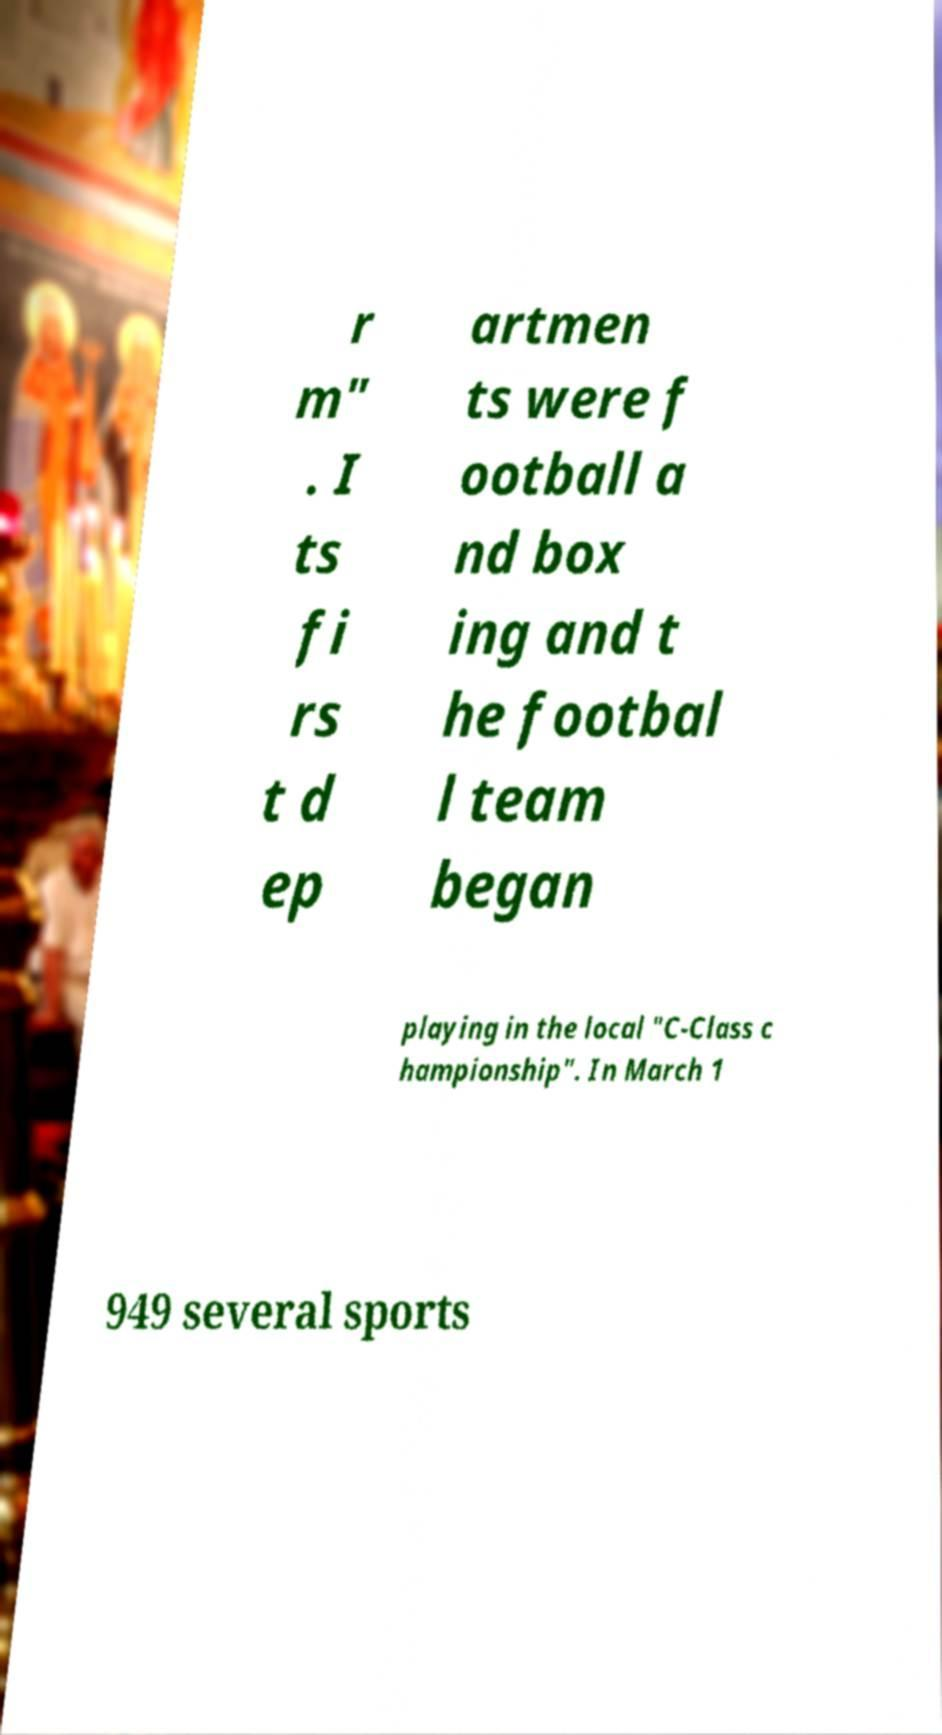What messages or text are displayed in this image? I need them in a readable, typed format. r m" . I ts fi rs t d ep artmen ts were f ootball a nd box ing and t he footbal l team began playing in the local "C-Class c hampionship". In March 1 949 several sports 